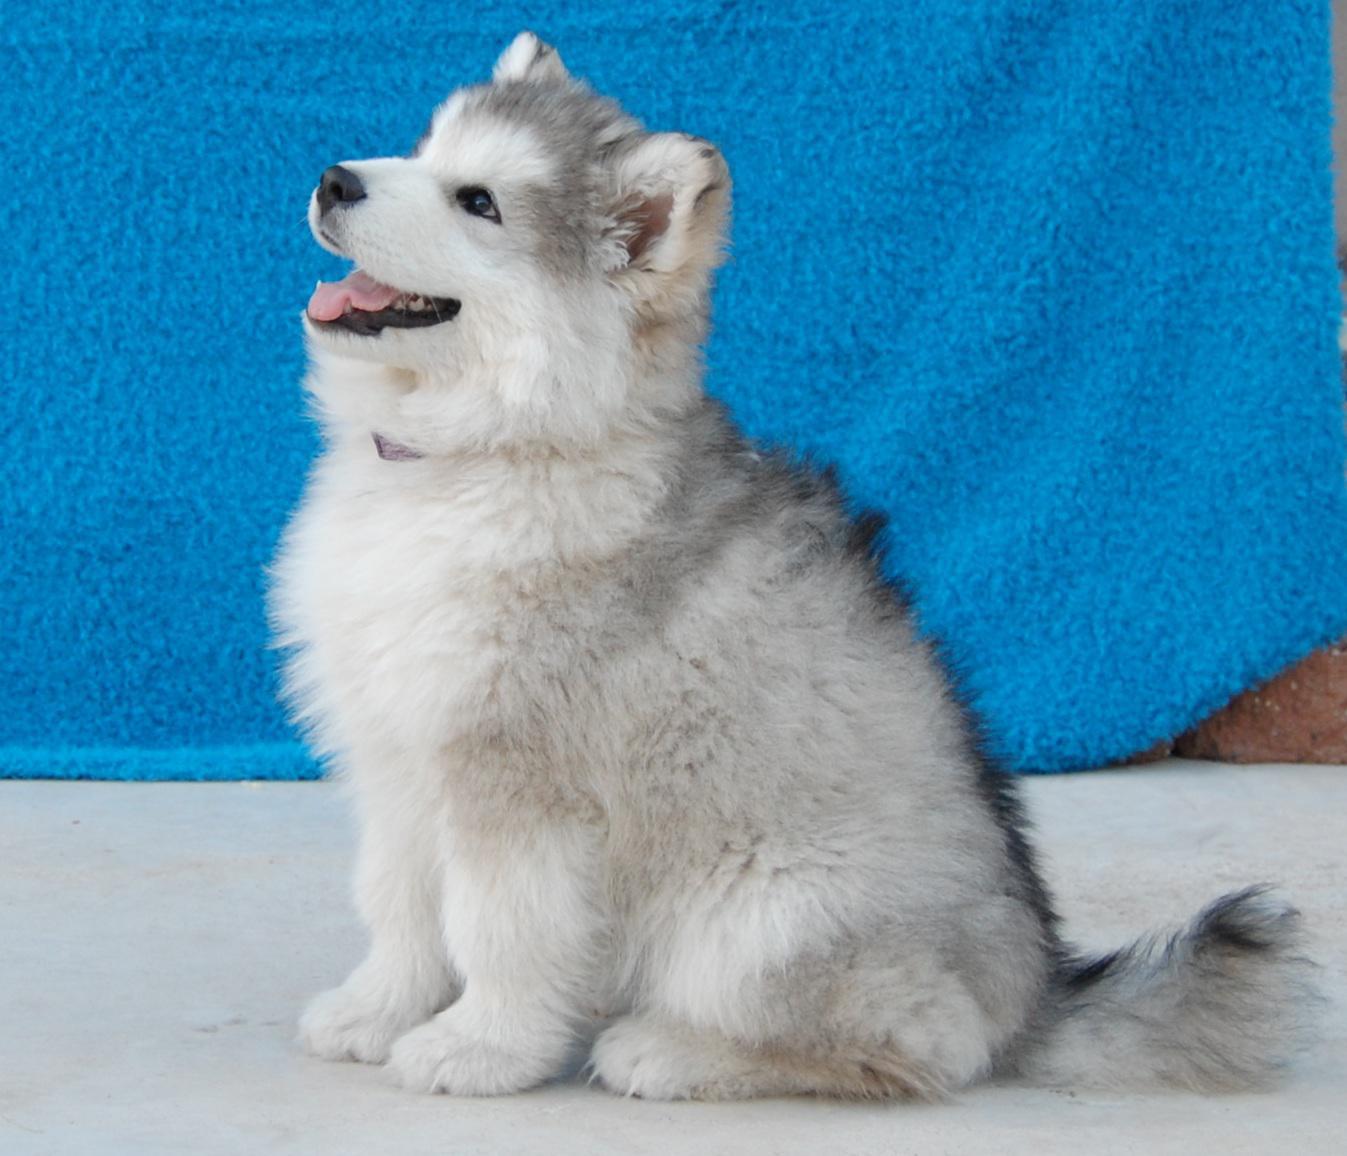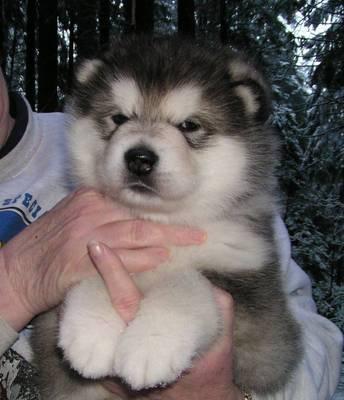The first image is the image on the left, the second image is the image on the right. Examine the images to the left and right. Is the description "The left image features a puppy sitting upright in profile, and the right image features a grey-and-white husky facing forward." accurate? Answer yes or no. Yes. The first image is the image on the left, the second image is the image on the right. Given the left and right images, does the statement "Exactly one dog is sitting." hold true? Answer yes or no. Yes. 